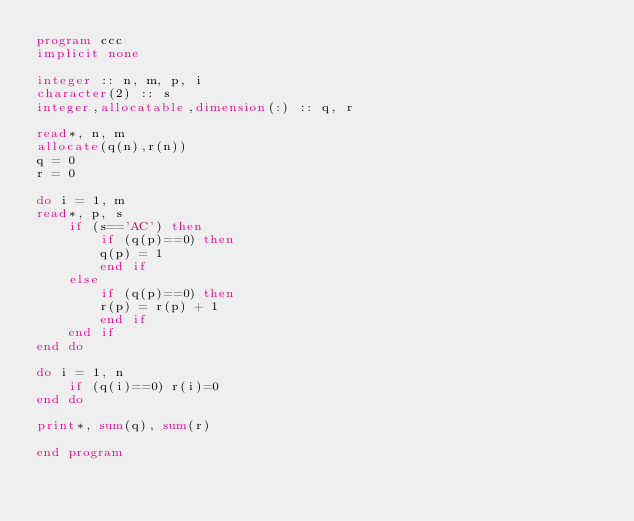Convert code to text. <code><loc_0><loc_0><loc_500><loc_500><_FORTRAN_>program ccc
implicit none

integer :: n, m, p, i
character(2) :: s
integer,allocatable,dimension(:) :: q, r

read*, n, m
allocate(q(n),r(n))
q = 0
r = 0

do i = 1, m
read*, p, s
	if (s=='AC') then
    	if (q(p)==0) then
        q(p) = 1
        end if
    else
    	if (q(p)==0) then
	    r(p) = r(p) + 1
        end if
    end if
end do

do i = 1, n
	if (q(i)==0) r(i)=0
end do

print*, sum(q), sum(r)

end program</code> 